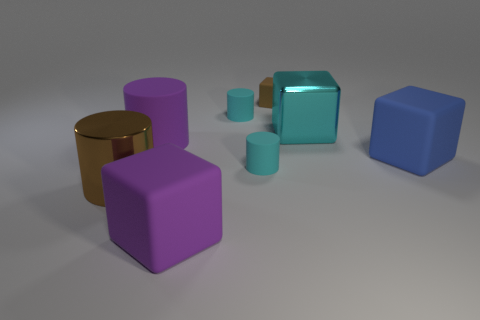Is the blue matte object the same shape as the tiny brown object?
Your response must be concise. Yes. There is a cyan rubber cylinder that is behind the cyan thing that is in front of the large cyan block; how big is it?
Your answer should be very brief. Small. There is a cylinder that is the same color as the small block; what material is it?
Your answer should be compact. Metal. Are there any purple rubber cylinders left of the small thing that is to the left of the tiny matte thing in front of the big blue matte object?
Your response must be concise. Yes. Is the material of the purple thing behind the large blue cube the same as the large blue cube that is in front of the purple rubber cylinder?
Make the answer very short. Yes. How many things are either big blue things or big shiny things in front of the tiny brown object?
Your answer should be very brief. 3. How many purple things have the same shape as the large brown thing?
Offer a terse response. 1. What material is the cylinder that is the same size as the brown metal thing?
Your response must be concise. Rubber. There is a blue cube right of the big metal object to the right of the small rubber thing that is in front of the big cyan block; how big is it?
Keep it short and to the point. Large. Does the small rubber cylinder that is in front of the purple cylinder have the same color as the big metal thing behind the brown metallic cylinder?
Your answer should be very brief. Yes. 